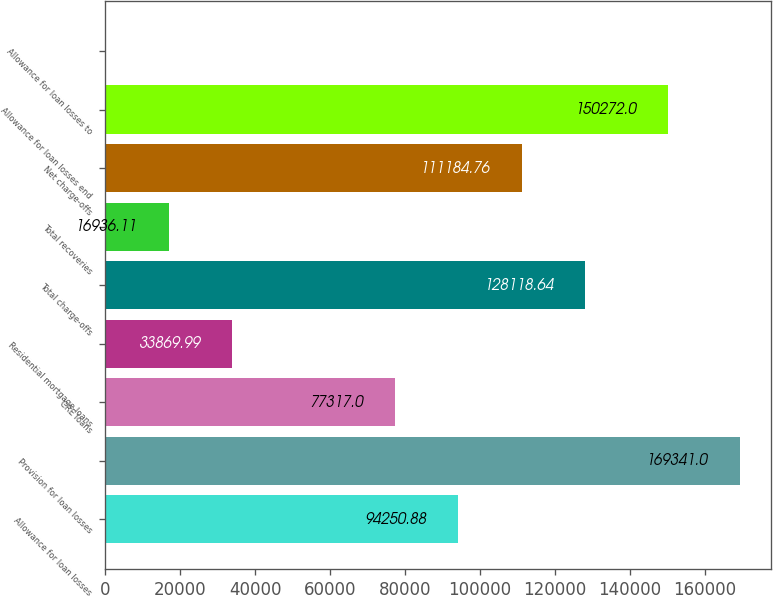Convert chart. <chart><loc_0><loc_0><loc_500><loc_500><bar_chart><fcel>Allowance for loan losses<fcel>Provision for loan losses<fcel>CRE loans<fcel>Residential mortgage loans<fcel>Total charge-offs<fcel>Total recoveries<fcel>Net charge-offs<fcel>Allowance for loan losses end<fcel>Allowance for loan losses to<nl><fcel>94250.9<fcel>169341<fcel>77317<fcel>33870<fcel>128119<fcel>16936.1<fcel>111185<fcel>150272<fcel>2.23<nl></chart> 